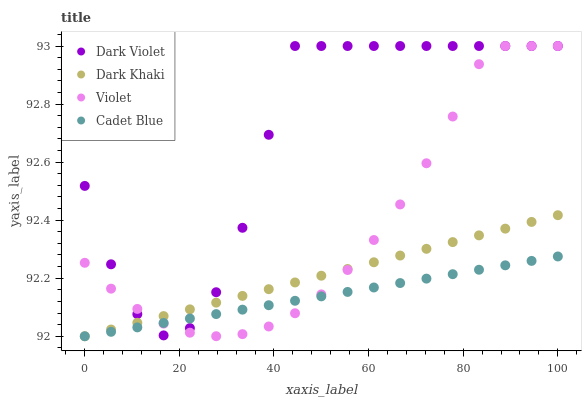Does Cadet Blue have the minimum area under the curve?
Answer yes or no. Yes. Does Dark Violet have the maximum area under the curve?
Answer yes or no. Yes. Does Dark Violet have the minimum area under the curve?
Answer yes or no. No. Does Cadet Blue have the maximum area under the curve?
Answer yes or no. No. Is Dark Khaki the smoothest?
Answer yes or no. Yes. Is Dark Violet the roughest?
Answer yes or no. Yes. Is Cadet Blue the smoothest?
Answer yes or no. No. Is Cadet Blue the roughest?
Answer yes or no. No. Does Dark Khaki have the lowest value?
Answer yes or no. Yes. Does Dark Violet have the lowest value?
Answer yes or no. No. Does Violet have the highest value?
Answer yes or no. Yes. Does Cadet Blue have the highest value?
Answer yes or no. No. Does Cadet Blue intersect Violet?
Answer yes or no. Yes. Is Cadet Blue less than Violet?
Answer yes or no. No. Is Cadet Blue greater than Violet?
Answer yes or no. No. 